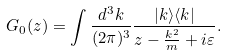Convert formula to latex. <formula><loc_0><loc_0><loc_500><loc_500>G _ { 0 } ( z ) = \int \frac { d ^ { 3 } k } { ( 2 \pi ) ^ { 3 } } \frac { | { k } \rangle \langle { k } | } { z - \frac { { k } ^ { 2 } } { m } + i \varepsilon } .</formula> 